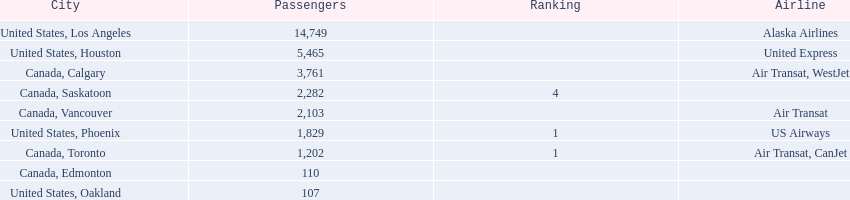Which cities had less than 2,000 passengers? United States, Phoenix, Canada, Toronto, Canada, Edmonton, United States, Oakland. Of these cities, which had fewer than 1,000 passengers? Canada, Edmonton, United States, Oakland. Of the cities in the previous answer, which one had only 107 passengers? United States, Oakland. 